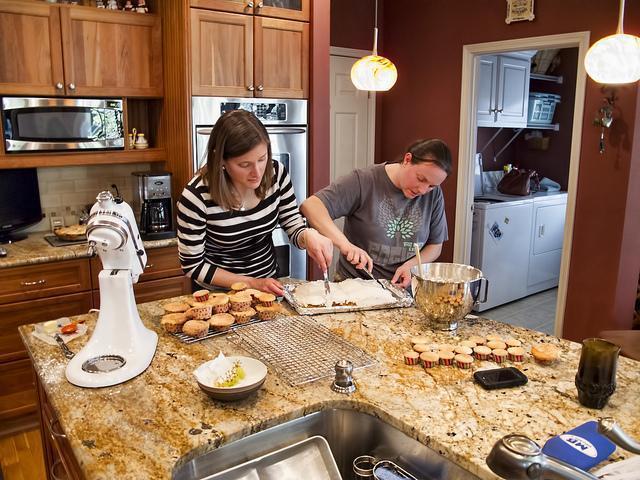What have these ladies been doing?
Select the accurate answer and provide justification: `Answer: choice
Rationale: srationale.`
Options: Drinking, baking, sleeping, watching tv. Answer: baking.
Rationale: The women are baking. 